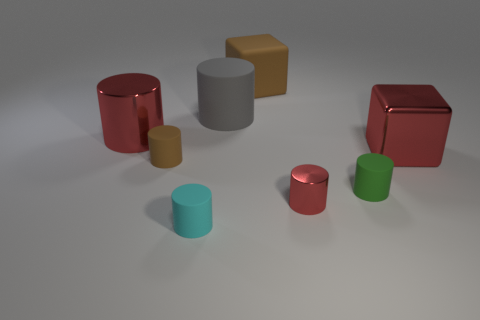Subtract 4 cylinders. How many cylinders are left? 2 Subtract all small metal cylinders. How many cylinders are left? 5 Subtract all gray cylinders. How many cylinders are left? 5 Add 1 big rubber objects. How many objects exist? 9 Subtract all yellow cylinders. Subtract all yellow spheres. How many cylinders are left? 6 Subtract all cubes. How many objects are left? 6 Subtract all big gray matte things. Subtract all large things. How many objects are left? 3 Add 8 tiny metallic objects. How many tiny metallic objects are left? 9 Add 4 cyan matte cylinders. How many cyan matte cylinders exist? 5 Subtract 1 gray cylinders. How many objects are left? 7 